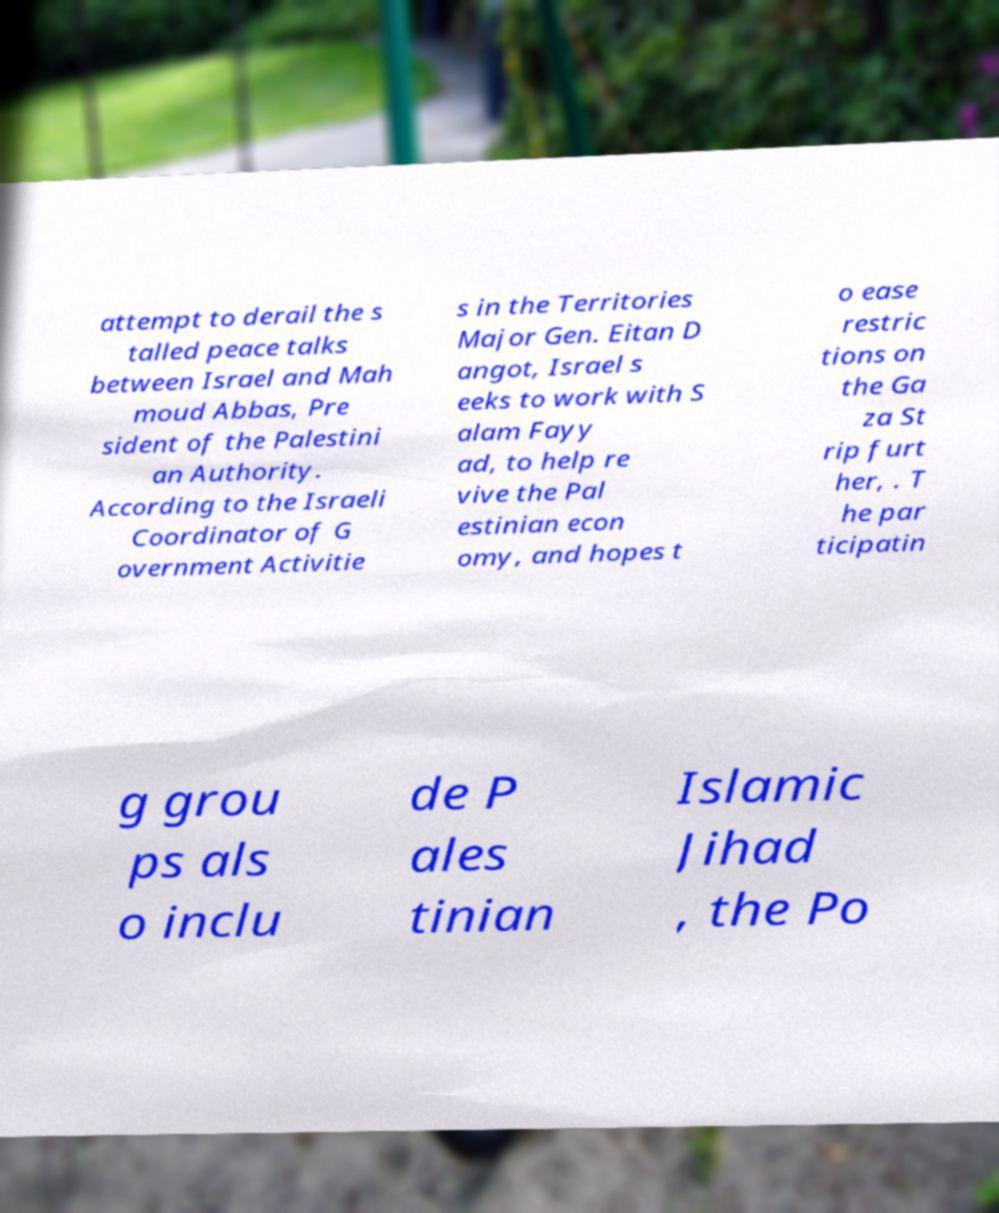Can you read and provide the text displayed in the image?This photo seems to have some interesting text. Can you extract and type it out for me? attempt to derail the s talled peace talks between Israel and Mah moud Abbas, Pre sident of the Palestini an Authority. According to the Israeli Coordinator of G overnment Activitie s in the Territories Major Gen. Eitan D angot, Israel s eeks to work with S alam Fayy ad, to help re vive the Pal estinian econ omy, and hopes t o ease restric tions on the Ga za St rip furt her, . T he par ticipatin g grou ps als o inclu de P ales tinian Islamic Jihad , the Po 